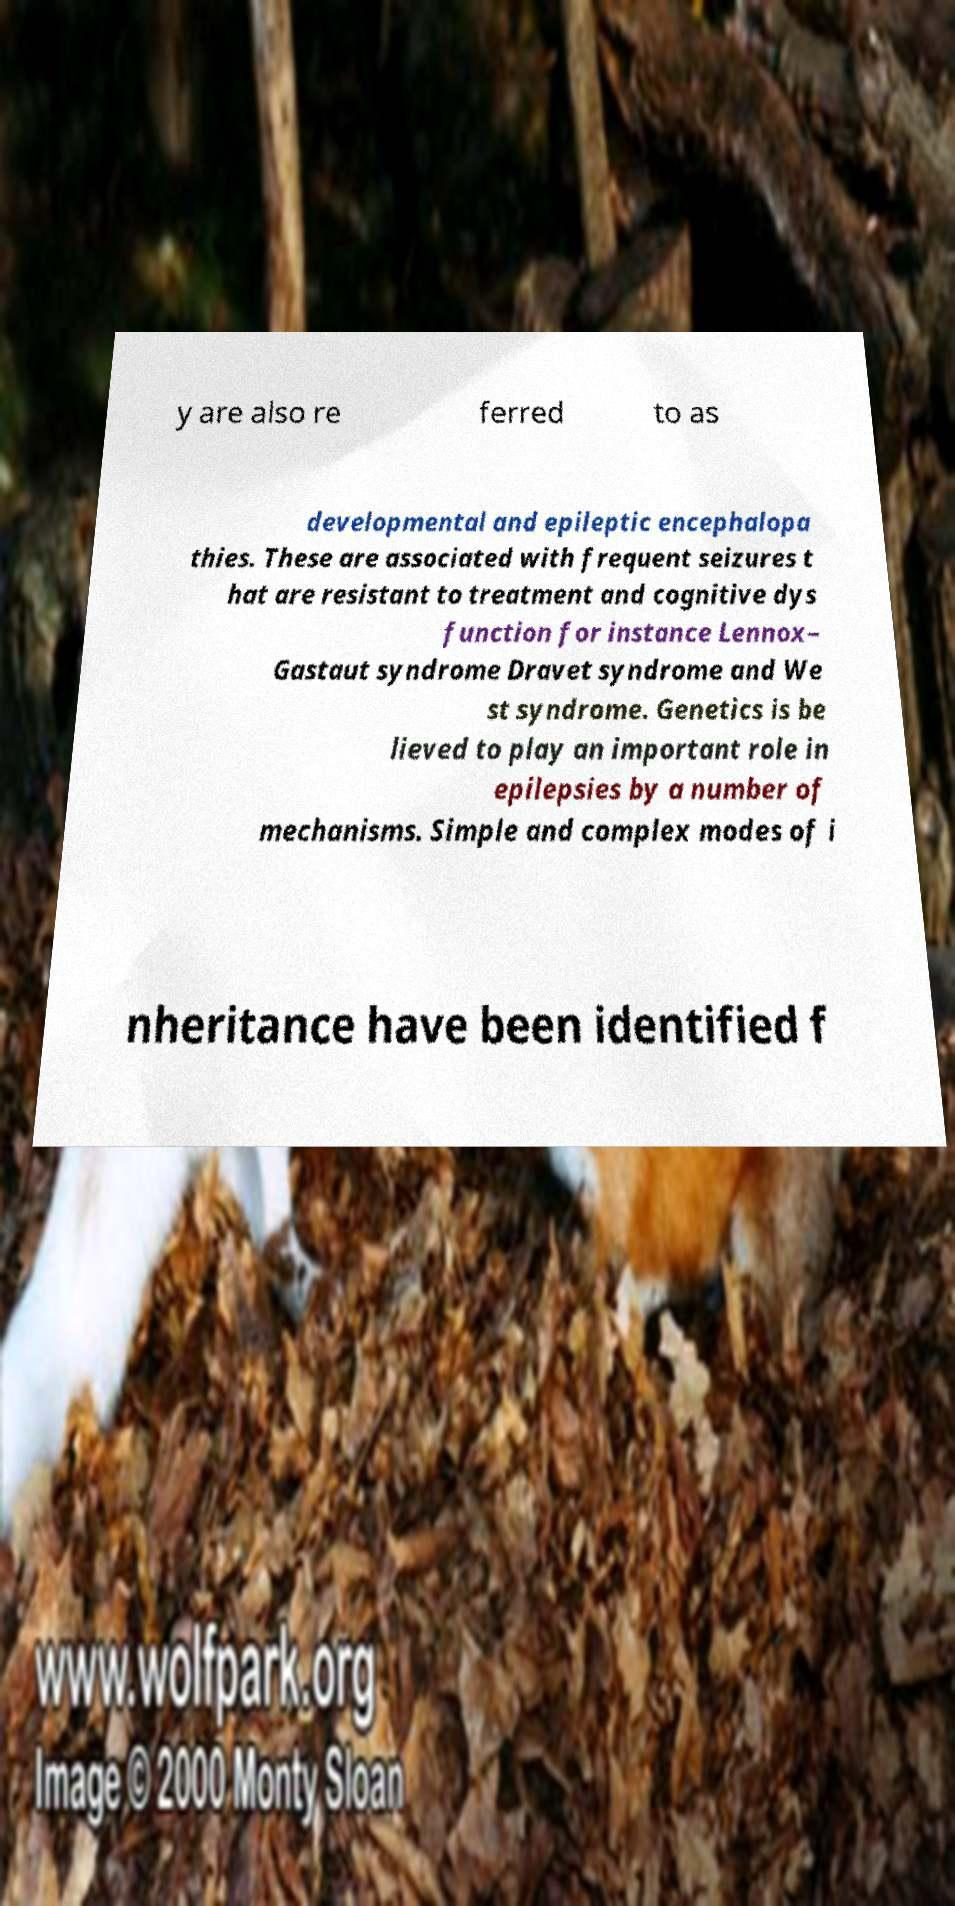I need the written content from this picture converted into text. Can you do that? y are also re ferred to as developmental and epileptic encephalopa thies. These are associated with frequent seizures t hat are resistant to treatment and cognitive dys function for instance Lennox– Gastaut syndrome Dravet syndrome and We st syndrome. Genetics is be lieved to play an important role in epilepsies by a number of mechanisms. Simple and complex modes of i nheritance have been identified f 